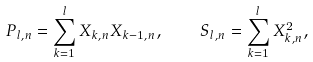<formula> <loc_0><loc_0><loc_500><loc_500>P _ { l , n } = \sum _ { k = 1 } ^ { l } { X _ { k , n } X _ { k - 1 , n } } , \quad S _ { l , n } = \sum _ { k = 1 } ^ { l } { X _ { k , n } ^ { 2 } } ,</formula> 